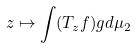Convert formula to latex. <formula><loc_0><loc_0><loc_500><loc_500>z \mapsto \int ( T _ { z } f ) g d \mu _ { 2 }</formula> 